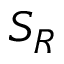Convert formula to latex. <formula><loc_0><loc_0><loc_500><loc_500>S _ { R }</formula> 